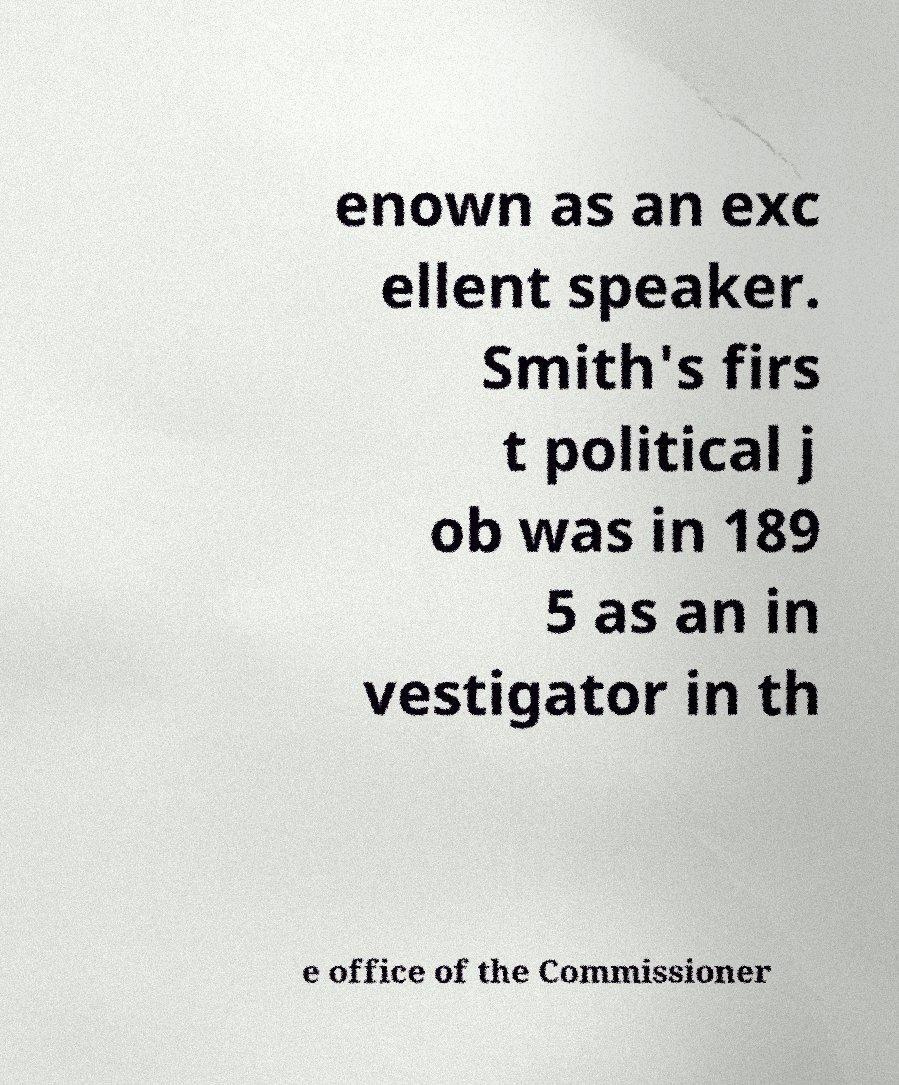For documentation purposes, I need the text within this image transcribed. Could you provide that? enown as an exc ellent speaker. Smith's firs t political j ob was in 189 5 as an in vestigator in th e office of the Commissioner 